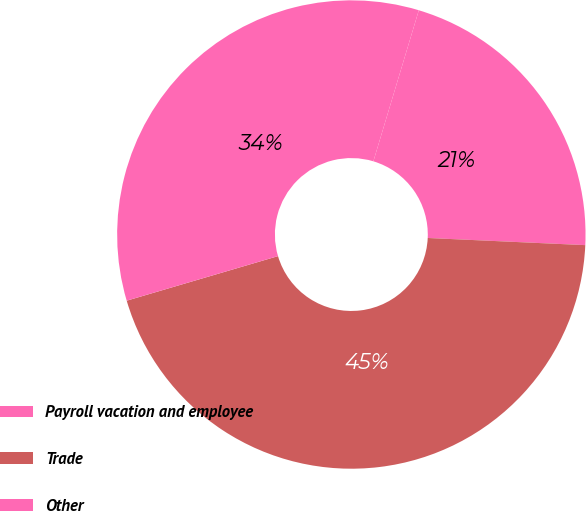<chart> <loc_0><loc_0><loc_500><loc_500><pie_chart><fcel>Payroll vacation and employee<fcel>Trade<fcel>Other<nl><fcel>21.07%<fcel>44.72%<fcel>34.21%<nl></chart> 